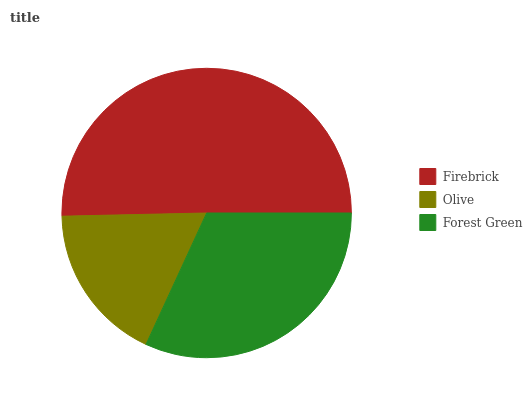Is Olive the minimum?
Answer yes or no. Yes. Is Firebrick the maximum?
Answer yes or no. Yes. Is Forest Green the minimum?
Answer yes or no. No. Is Forest Green the maximum?
Answer yes or no. No. Is Forest Green greater than Olive?
Answer yes or no. Yes. Is Olive less than Forest Green?
Answer yes or no. Yes. Is Olive greater than Forest Green?
Answer yes or no. No. Is Forest Green less than Olive?
Answer yes or no. No. Is Forest Green the high median?
Answer yes or no. Yes. Is Forest Green the low median?
Answer yes or no. Yes. Is Firebrick the high median?
Answer yes or no. No. Is Firebrick the low median?
Answer yes or no. No. 